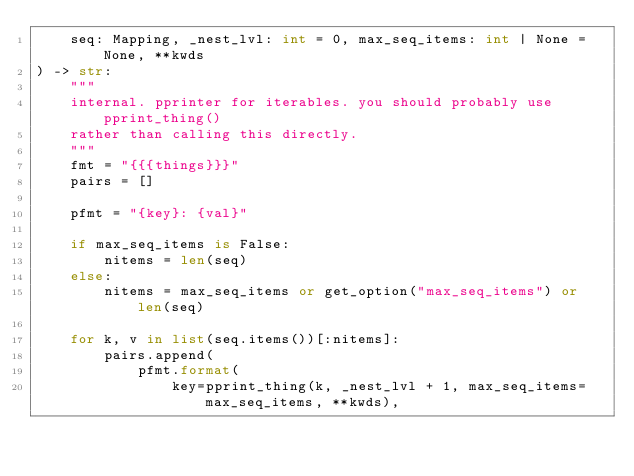<code> <loc_0><loc_0><loc_500><loc_500><_Python_>    seq: Mapping, _nest_lvl: int = 0, max_seq_items: int | None = None, **kwds
) -> str:
    """
    internal. pprinter for iterables. you should probably use pprint_thing()
    rather than calling this directly.
    """
    fmt = "{{{things}}}"
    pairs = []

    pfmt = "{key}: {val}"

    if max_seq_items is False:
        nitems = len(seq)
    else:
        nitems = max_seq_items or get_option("max_seq_items") or len(seq)

    for k, v in list(seq.items())[:nitems]:
        pairs.append(
            pfmt.format(
                key=pprint_thing(k, _nest_lvl + 1, max_seq_items=max_seq_items, **kwds),</code> 